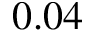<formula> <loc_0><loc_0><loc_500><loc_500>0 . 0 4</formula> 